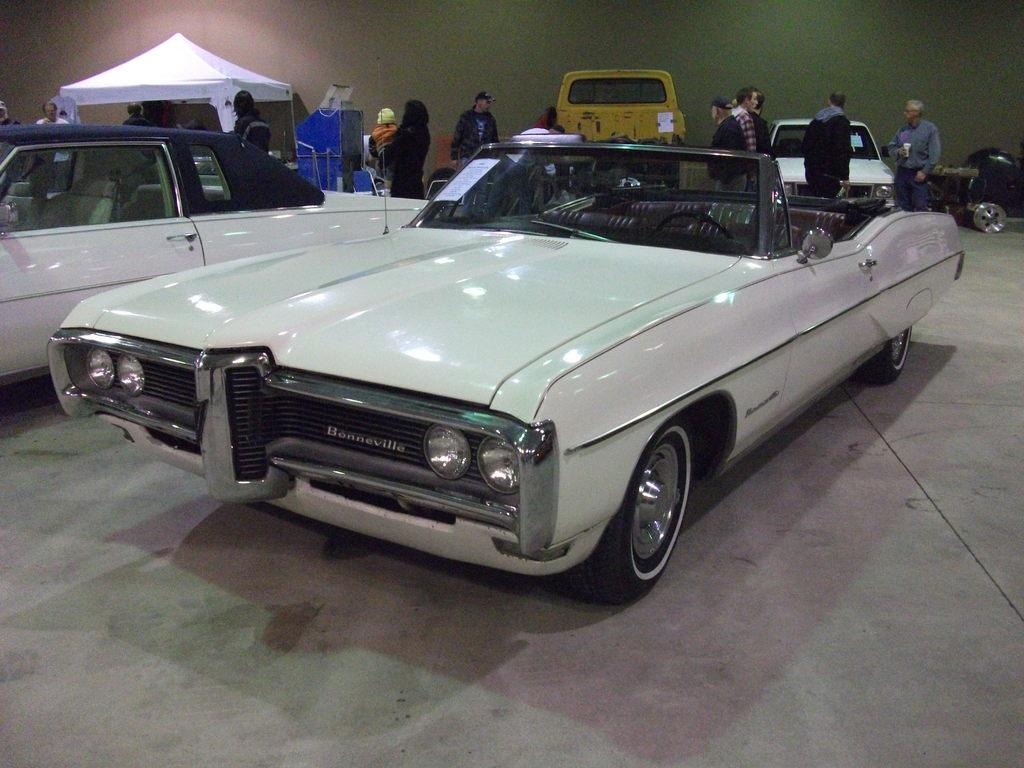How many people are in the group that is visible in the image? There is a group of persons standing in the image, but the exact number cannot be determined from the provided facts. What else can be seen in the image besides the group of persons? There are cars and a tent visible in the image. What is visible in the background of the image? There is a wall visible in the background of the image. What color crayon is being used to draw on the tent in the image? There is no crayon or drawing activity present in the image; it features a group of persons, cars, and a tent. 